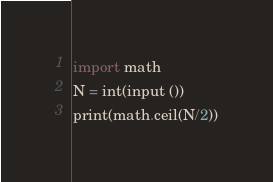<code> <loc_0><loc_0><loc_500><loc_500><_Python_>import math
N = int(input ())
print(math.ceil(N/2))
</code> 